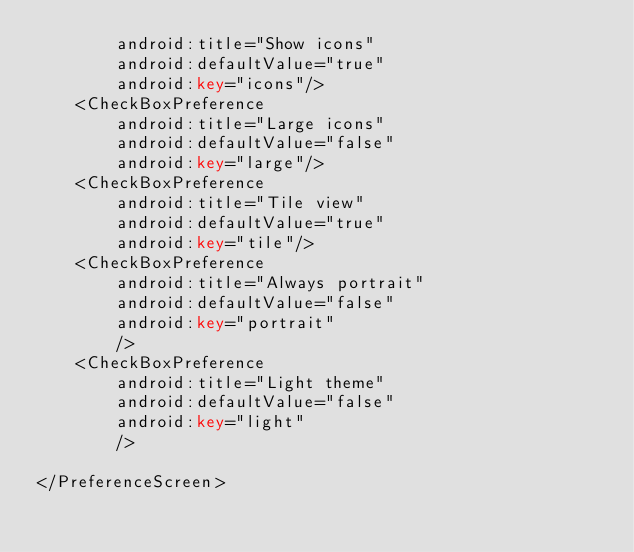<code> <loc_0><loc_0><loc_500><loc_500><_XML_>        android:title="Show icons"
        android:defaultValue="true"
        android:key="icons"/>
    <CheckBoxPreference
        android:title="Large icons"
        android:defaultValue="false"
        android:key="large"/>
    <CheckBoxPreference
    	android:title="Tile view"
    	android:defaultValue="true"
    	android:key="tile"/>
    <CheckBoxPreference 
        android:title="Always portrait"
        android:defaultValue="false"
        android:key="portrait"
        />
    <CheckBoxPreference 
        android:title="Light theme"
        android:defaultValue="false"
        android:key="light"
        />

</PreferenceScreen>
</code> 